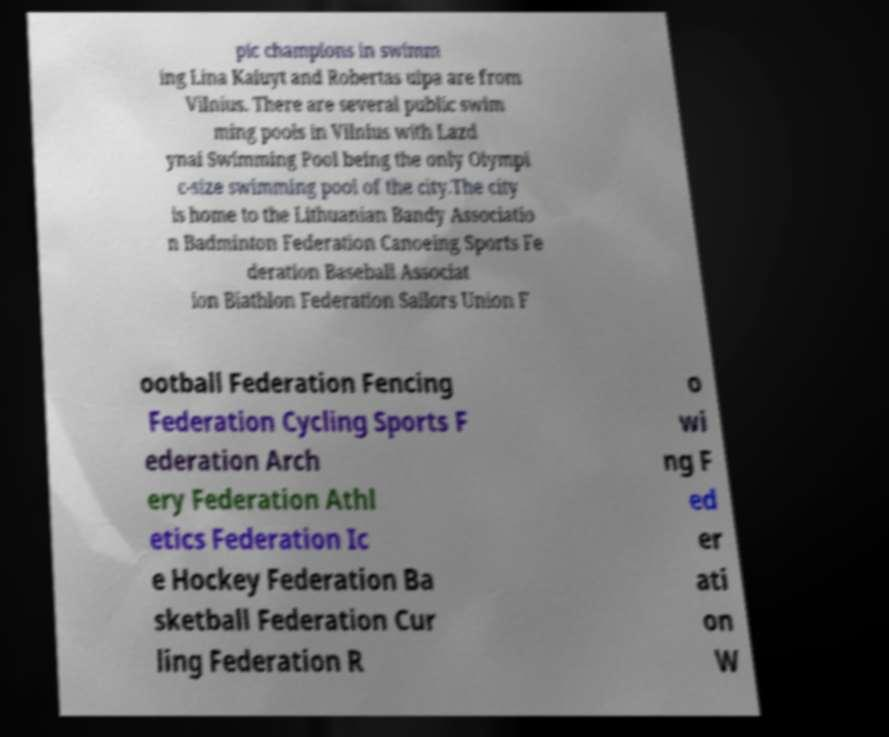Could you assist in decoding the text presented in this image and type it out clearly? pic champions in swimm ing Lina Kaiuyt and Robertas ulpa are from Vilnius. There are several public swim ming pools in Vilnius with Lazd ynai Swimming Pool being the only Olympi c-size swimming pool of the city.The city is home to the Lithuanian Bandy Associatio n Badminton Federation Canoeing Sports Fe deration Baseball Associat ion Biathlon Federation Sailors Union F ootball Federation Fencing Federation Cycling Sports F ederation Arch ery Federation Athl etics Federation Ic e Hockey Federation Ba sketball Federation Cur ling Federation R o wi ng F ed er ati on W 